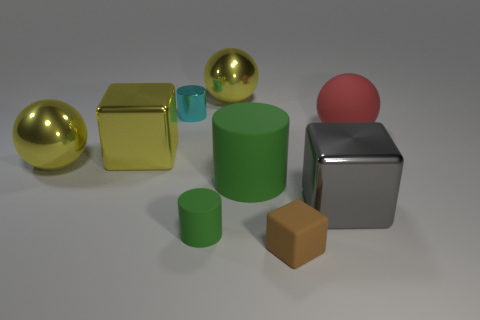Subtract 1 spheres. How many spheres are left? 2 Add 1 brown matte objects. How many objects exist? 10 Subtract all spheres. How many objects are left? 6 Subtract 0 cyan spheres. How many objects are left? 9 Subtract all big brown metallic balls. Subtract all green things. How many objects are left? 7 Add 7 large rubber balls. How many large rubber balls are left? 8 Add 4 big things. How many big things exist? 10 